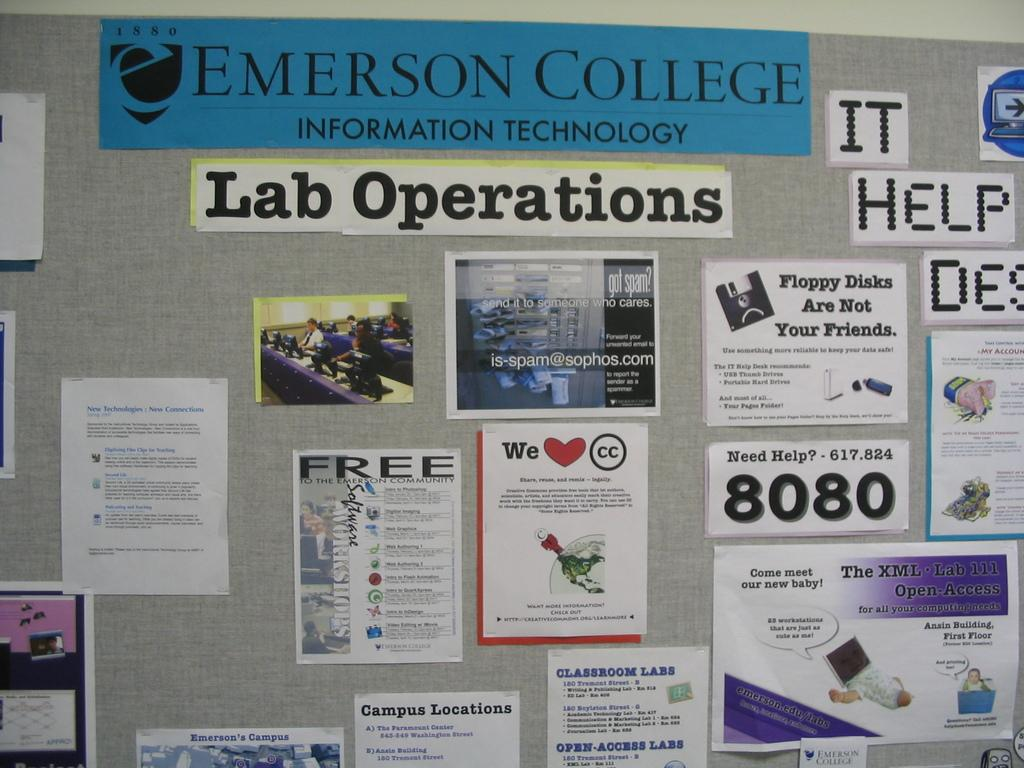<image>
Write a terse but informative summary of the picture. An Emerson College lab operations bulletin board with various postings on it. 